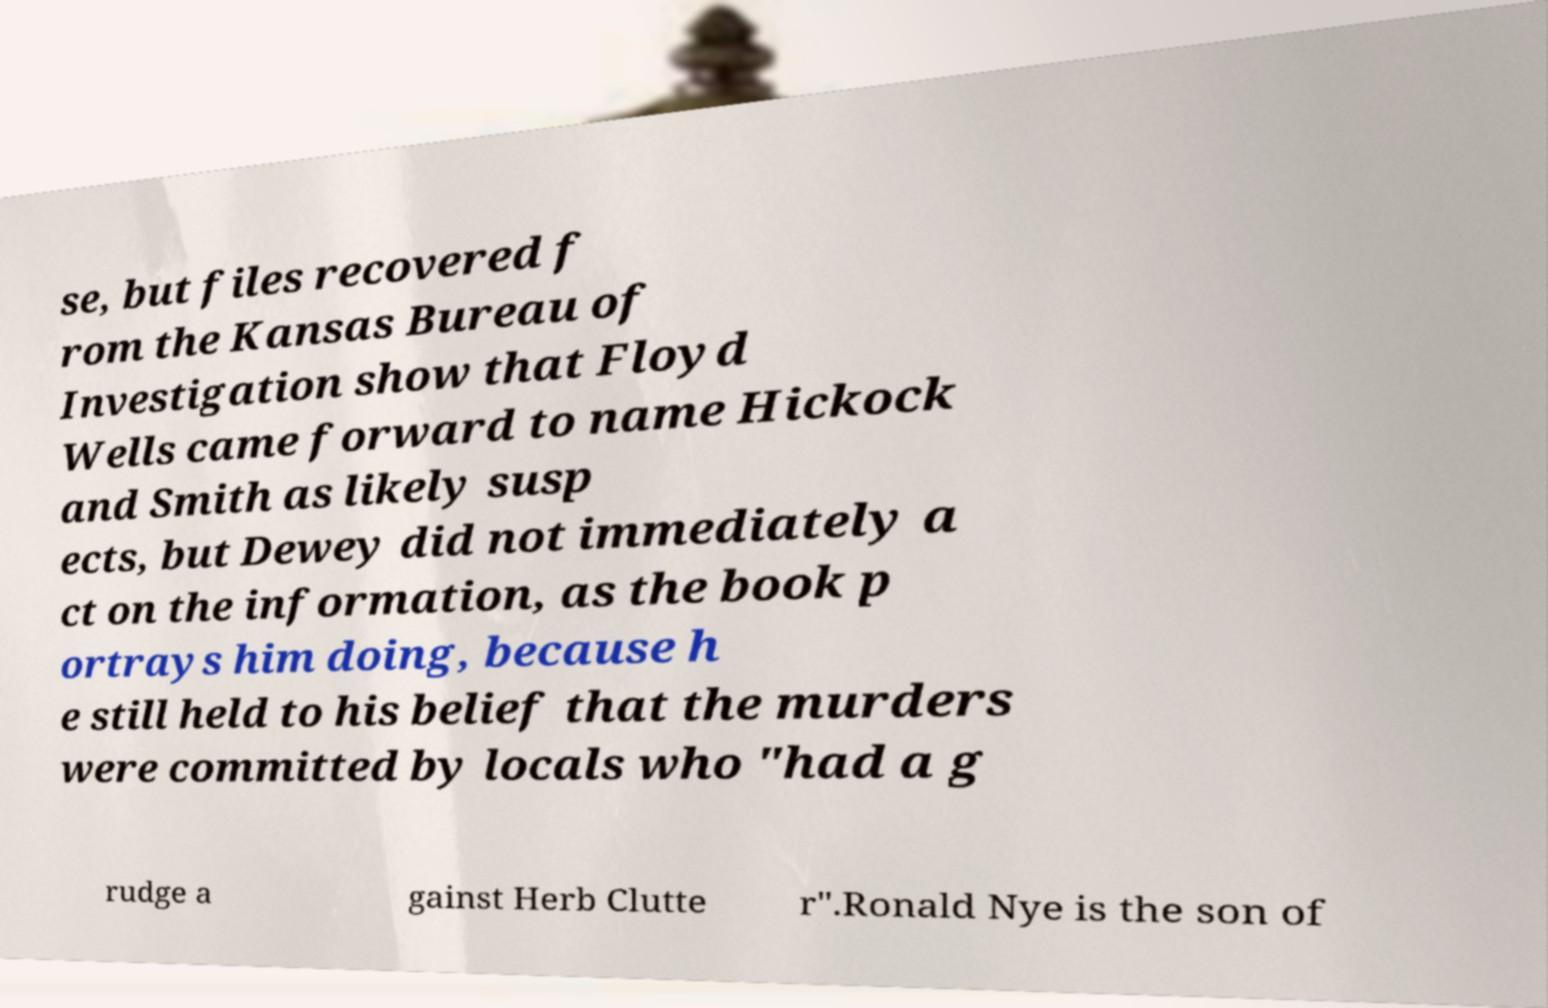There's text embedded in this image that I need extracted. Can you transcribe it verbatim? se, but files recovered f rom the Kansas Bureau of Investigation show that Floyd Wells came forward to name Hickock and Smith as likely susp ects, but Dewey did not immediately a ct on the information, as the book p ortrays him doing, because h e still held to his belief that the murders were committed by locals who "had a g rudge a gainst Herb Clutte r".Ronald Nye is the son of 